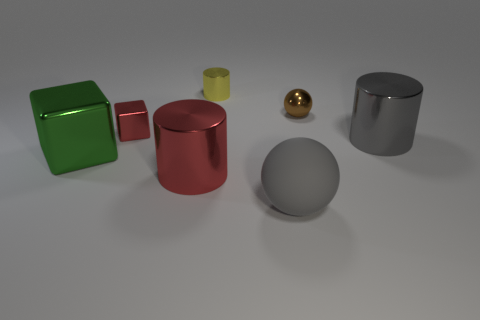Is the number of small brown matte cubes less than the number of small yellow metallic cylinders?
Your answer should be very brief. Yes. There is a cylinder that is in front of the yellow metal thing and behind the big red metallic thing; what color is it?
Make the answer very short. Gray. There is a large gray thing that is the same shape as the yellow metal thing; what is its material?
Give a very brief answer. Metal. Is there any other thing that has the same size as the green shiny block?
Your answer should be compact. Yes. Is the number of small cyan metal balls greater than the number of green cubes?
Ensure brevity in your answer.  No. How big is the thing that is both in front of the small cylinder and behind the small red block?
Offer a very short reply. Small. There is a large gray rubber object; what shape is it?
Provide a succinct answer. Sphere. How many red metal objects have the same shape as the green shiny object?
Your answer should be compact. 1. Is the number of red blocks in front of the gray matte object less than the number of balls that are left of the small metallic block?
Ensure brevity in your answer.  No. How many tiny brown objects are in front of the gray object that is to the right of the tiny brown shiny sphere?
Offer a terse response. 0. 